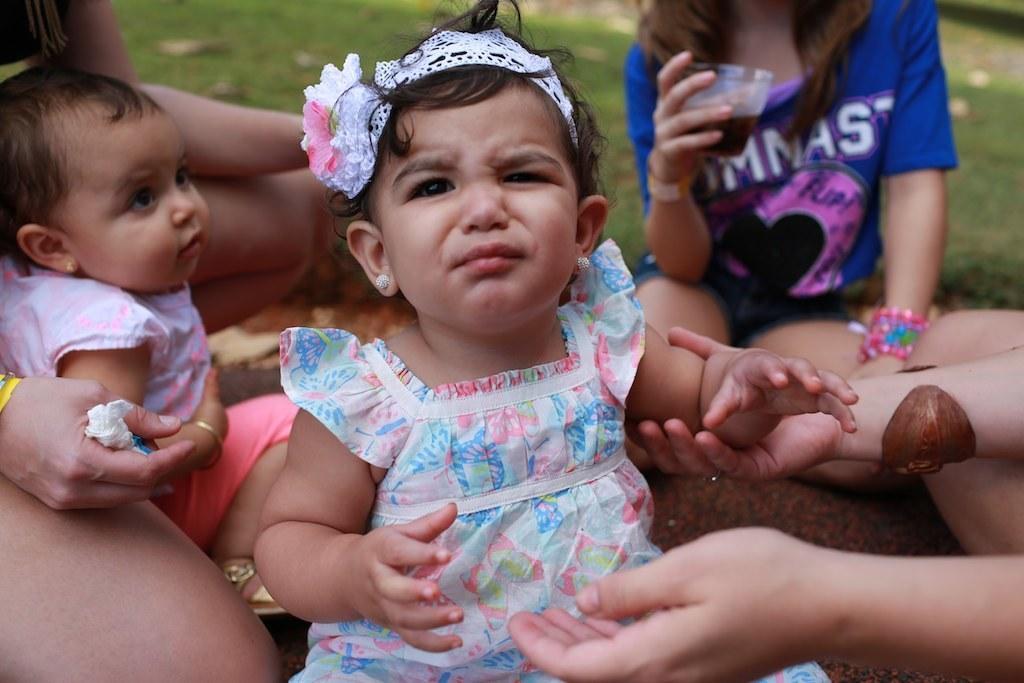How would you summarize this image in a sentence or two? In this image children are sitting on the floor and at the back side there is a grass on the surface. 